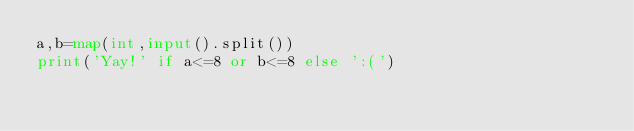Convert code to text. <code><loc_0><loc_0><loc_500><loc_500><_Python_>a,b=map(int,input().split())
print('Yay!' if a<=8 or b<=8 else ':(')</code> 